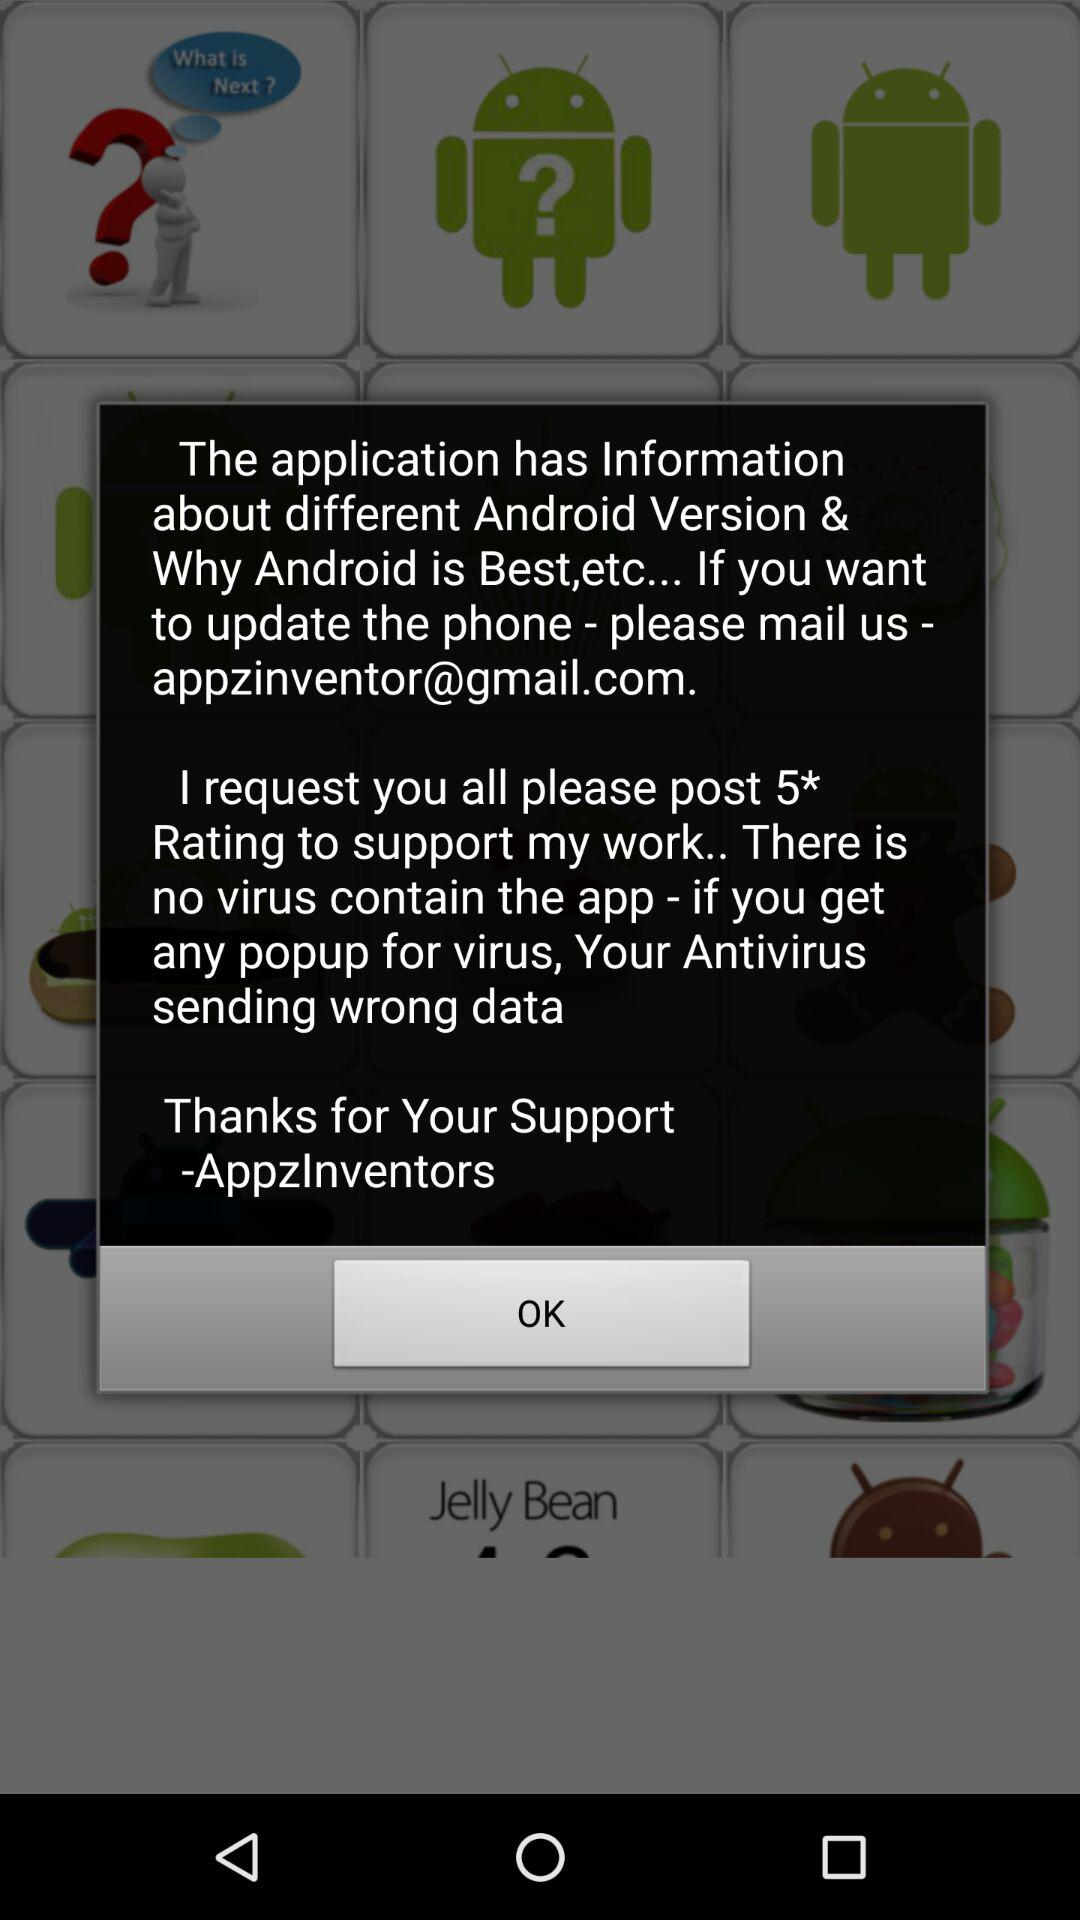What's the Google mail address? The Google mail address is appzinventor@gmail.com. 